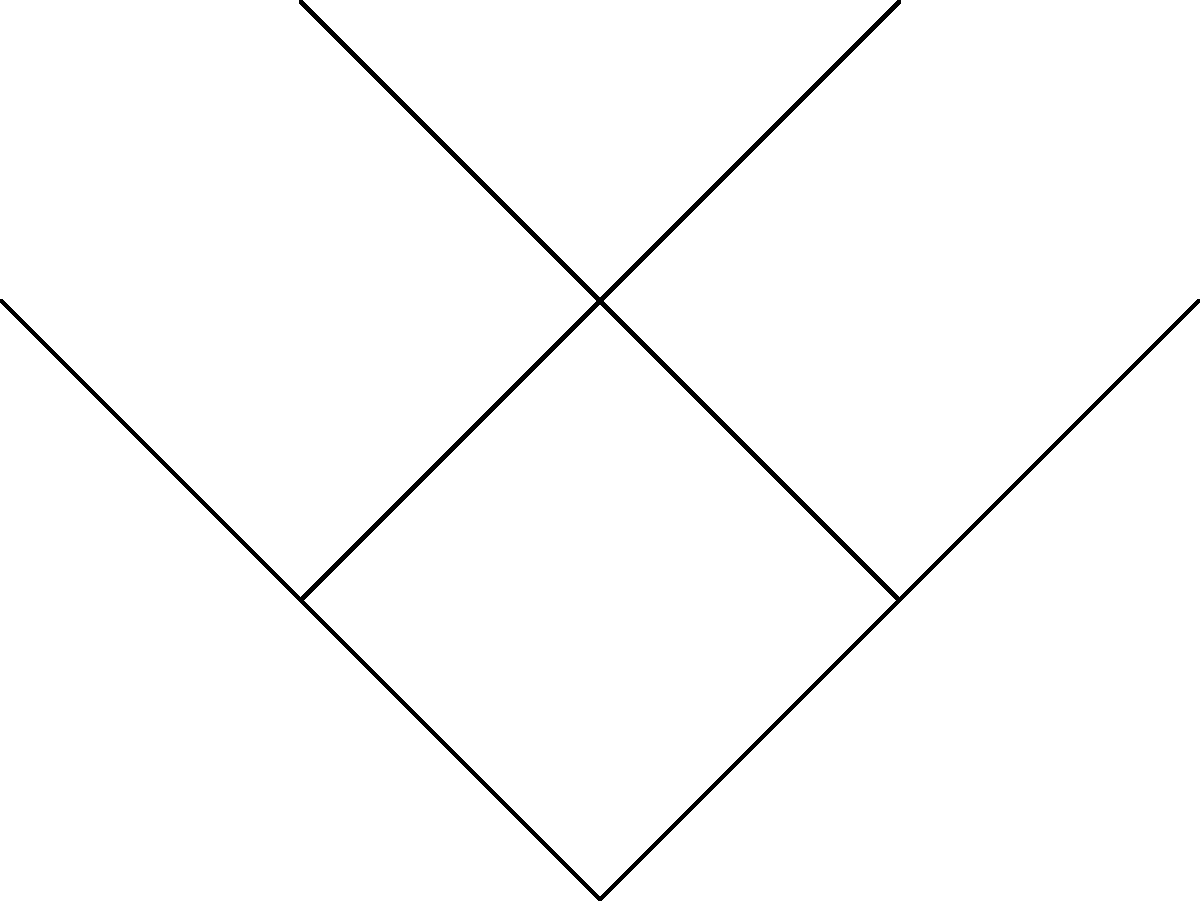In a family tree represented as a graph, information about a harmful addiction spreads from parent to child with a probability of $\frac{1}{2}$. If the information starts at vertex $v_1$ (the family matriarch), what is the probability that it reaches vertex $v_8$ (her great-grandchild)? To solve this problem, we need to follow these steps:

1. Identify the path from $v_1$ to $v_8$:
   $v_1 \rightarrow v_2 \rightarrow v_4 \rightarrow v_8$

2. Count the number of edges in this path:
   There are 3 edges.

3. Calculate the probability of the information passing through each edge:
   The probability for each edge is $\frac{1}{2}$

4. To find the probability of the information reaching $v_8$, we need to multiply the probabilities of it passing through each edge in the path:

   $P(v_1 \rightarrow v_8) = \frac{1}{2} \times \frac{1}{2} \times \frac{1}{2}$

5. Simplify the calculation:
   $P(v_1 \rightarrow v_8) = (\frac{1}{2})^3 = \frac{1}{8}$

Therefore, the probability that the information about the harmful addiction reaches the great-grandchild ($v_8$) is $\frac{1}{8}$.
Answer: $\frac{1}{8}$ 